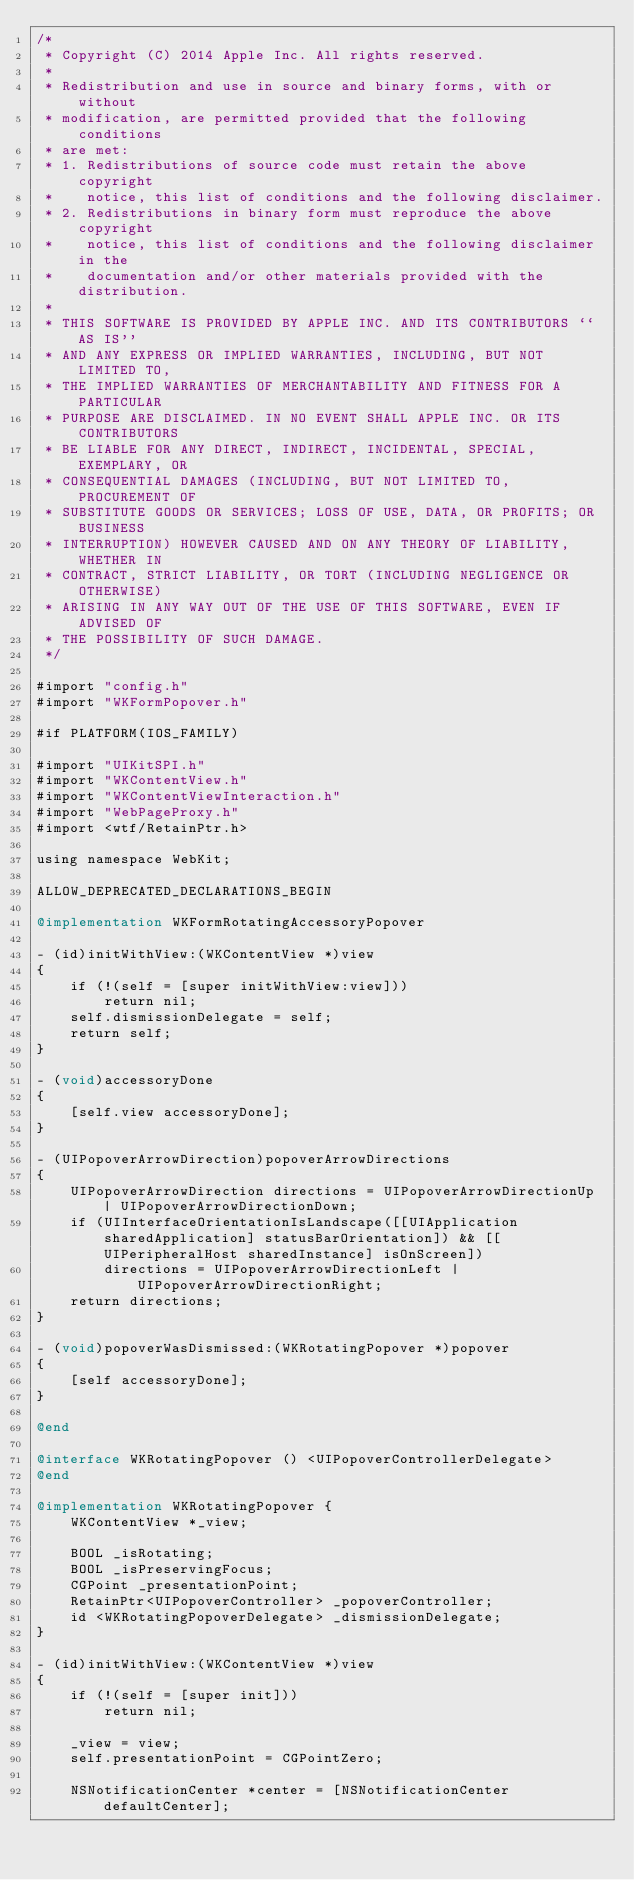<code> <loc_0><loc_0><loc_500><loc_500><_ObjectiveC_>/*
 * Copyright (C) 2014 Apple Inc. All rights reserved.
 *
 * Redistribution and use in source and binary forms, with or without
 * modification, are permitted provided that the following conditions
 * are met:
 * 1. Redistributions of source code must retain the above copyright
 *    notice, this list of conditions and the following disclaimer.
 * 2. Redistributions in binary form must reproduce the above copyright
 *    notice, this list of conditions and the following disclaimer in the
 *    documentation and/or other materials provided with the distribution.
 *
 * THIS SOFTWARE IS PROVIDED BY APPLE INC. AND ITS CONTRIBUTORS ``AS IS''
 * AND ANY EXPRESS OR IMPLIED WARRANTIES, INCLUDING, BUT NOT LIMITED TO,
 * THE IMPLIED WARRANTIES OF MERCHANTABILITY AND FITNESS FOR A PARTICULAR
 * PURPOSE ARE DISCLAIMED. IN NO EVENT SHALL APPLE INC. OR ITS CONTRIBUTORS
 * BE LIABLE FOR ANY DIRECT, INDIRECT, INCIDENTAL, SPECIAL, EXEMPLARY, OR
 * CONSEQUENTIAL DAMAGES (INCLUDING, BUT NOT LIMITED TO, PROCUREMENT OF
 * SUBSTITUTE GOODS OR SERVICES; LOSS OF USE, DATA, OR PROFITS; OR BUSINESS
 * INTERRUPTION) HOWEVER CAUSED AND ON ANY THEORY OF LIABILITY, WHETHER IN
 * CONTRACT, STRICT LIABILITY, OR TORT (INCLUDING NEGLIGENCE OR OTHERWISE)
 * ARISING IN ANY WAY OUT OF THE USE OF THIS SOFTWARE, EVEN IF ADVISED OF
 * THE POSSIBILITY OF SUCH DAMAGE.
 */

#import "config.h"
#import "WKFormPopover.h"

#if PLATFORM(IOS_FAMILY)

#import "UIKitSPI.h"
#import "WKContentView.h"
#import "WKContentViewInteraction.h"
#import "WebPageProxy.h"
#import <wtf/RetainPtr.h>

using namespace WebKit;

ALLOW_DEPRECATED_DECLARATIONS_BEGIN

@implementation WKFormRotatingAccessoryPopover

- (id)initWithView:(WKContentView *)view
{
    if (!(self = [super initWithView:view]))
        return nil;
    self.dismissionDelegate = self;
    return self;
}

- (void)accessoryDone
{
    [self.view accessoryDone];
}

- (UIPopoverArrowDirection)popoverArrowDirections
{
    UIPopoverArrowDirection directions = UIPopoverArrowDirectionUp | UIPopoverArrowDirectionDown;
    if (UIInterfaceOrientationIsLandscape([[UIApplication sharedApplication] statusBarOrientation]) && [[UIPeripheralHost sharedInstance] isOnScreen])
        directions = UIPopoverArrowDirectionLeft | UIPopoverArrowDirectionRight;
    return directions;
}

- (void)popoverWasDismissed:(WKRotatingPopover *)popover
{
    [self accessoryDone];
}

@end

@interface WKRotatingPopover () <UIPopoverControllerDelegate>
@end

@implementation WKRotatingPopover {
    WKContentView *_view;

    BOOL _isRotating;
    BOOL _isPreservingFocus;
    CGPoint _presentationPoint;
    RetainPtr<UIPopoverController> _popoverController;
    id <WKRotatingPopoverDelegate> _dismissionDelegate;
}

- (id)initWithView:(WKContentView *)view
{
    if (!(self = [super init]))
        return nil;

    _view = view;
    self.presentationPoint = CGPointZero;

    NSNotificationCenter *center = [NSNotificationCenter defaultCenter];</code> 